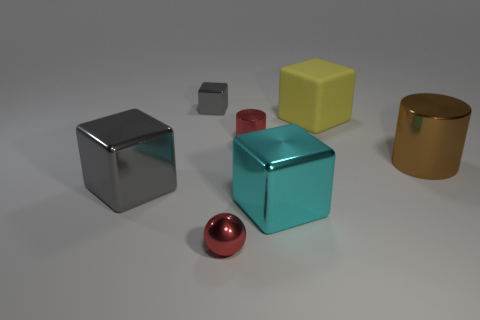Subtract all small gray shiny cubes. How many cubes are left? 3 Add 2 spheres. How many objects exist? 9 Subtract all gray blocks. How many blocks are left? 2 Subtract all purple spheres. How many gray cubes are left? 2 Subtract 2 cylinders. How many cylinders are left? 0 Subtract all spheres. How many objects are left? 6 Subtract 0 blue blocks. How many objects are left? 7 Subtract all yellow cubes. Subtract all yellow balls. How many cubes are left? 3 Subtract all big things. Subtract all large green blocks. How many objects are left? 3 Add 4 cyan objects. How many cyan objects are left? 5 